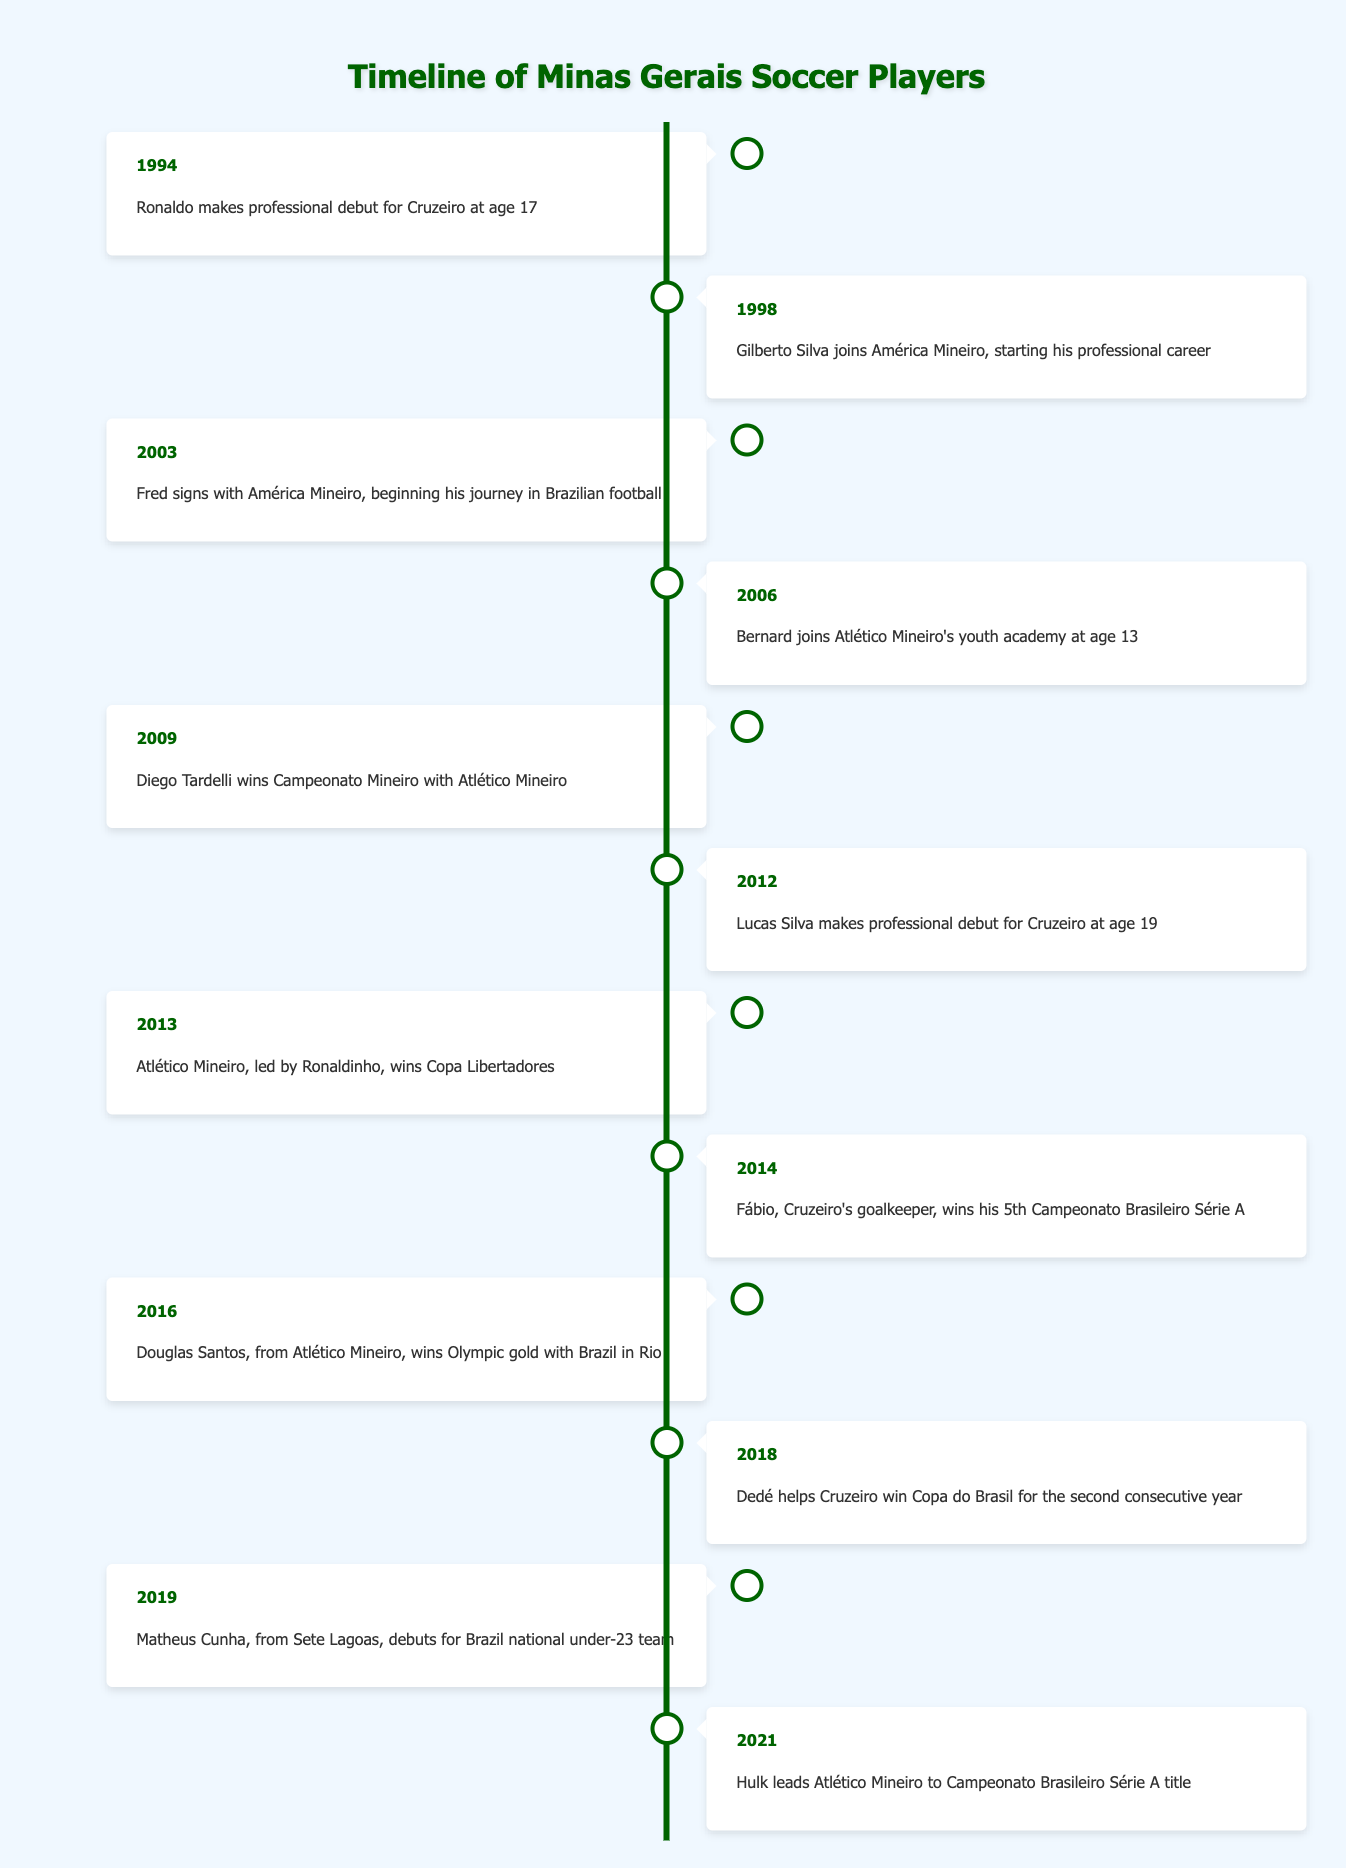What year did Ronaldo make his professional debut for Cruzeiro? The table states that Ronaldo made his professional debut for Cruzeiro in 1994, which is the first event listed.
Answer: 1994 In which year did Gilberto Silva start his professional career with América Mineiro? According to the table, Gilberto Silva joined América Mineiro in 1998, marking the start of his professional career.
Answer: 1998 Who won the Copa Libertadores in 2013, and who led the team? The table indicates that Atlético Mineiro won the Copa Libertadores in 2013, and it was led by Ronaldinho.
Answer: Atlético Mineiro, led by Ronaldinho How many Campeonato Brasileiro Série A titles did Fábio win by 2014? The table specifies that Fábio won his 5th Campeonato Brasileiro Série A title in 2014, so that is the answer.
Answer: 5 Did Bernard join Atlético Mineiro's youth academy before age 14? Yes, the table shows that Bernard joined Atlético Mineiro's youth academy in 2006 at age 13, which is before he turned 14.
Answer: Yes What is the time gap between Fábio's Campeonato Brasileiro title wins and the year Lucas Silva made his professional debut? Fábio won his 5th title in 2014, while Lucas Silva made his professional debut in 2012. The gap can be calculated as 2014 - 2012 = 2 years.
Answer: 2 years Which player helped Cruzeiro win Copa do Brasil in 2018? According to the table, Dedé helped Cruzeiro win the Copa do Brasil for the second consecutive year in 2018.
Answer: Dedé How many years passed between Ronaldo's debut and Atlético Mineiro winning the Copa Libertadores? Ronaldo debuted in 1994, and Atlético Mineiro won the Copa Libertadores in 2013. The time difference is calculated as 2013 - 1994 = 19 years.
Answer: 19 years Was Diego Tardelli part of a championship-winning team in 2009? Yes, the table indicates that Diego Tardelli won the Campeonato Mineiro with Atlético Mineiro in 2009.
Answer: Yes 